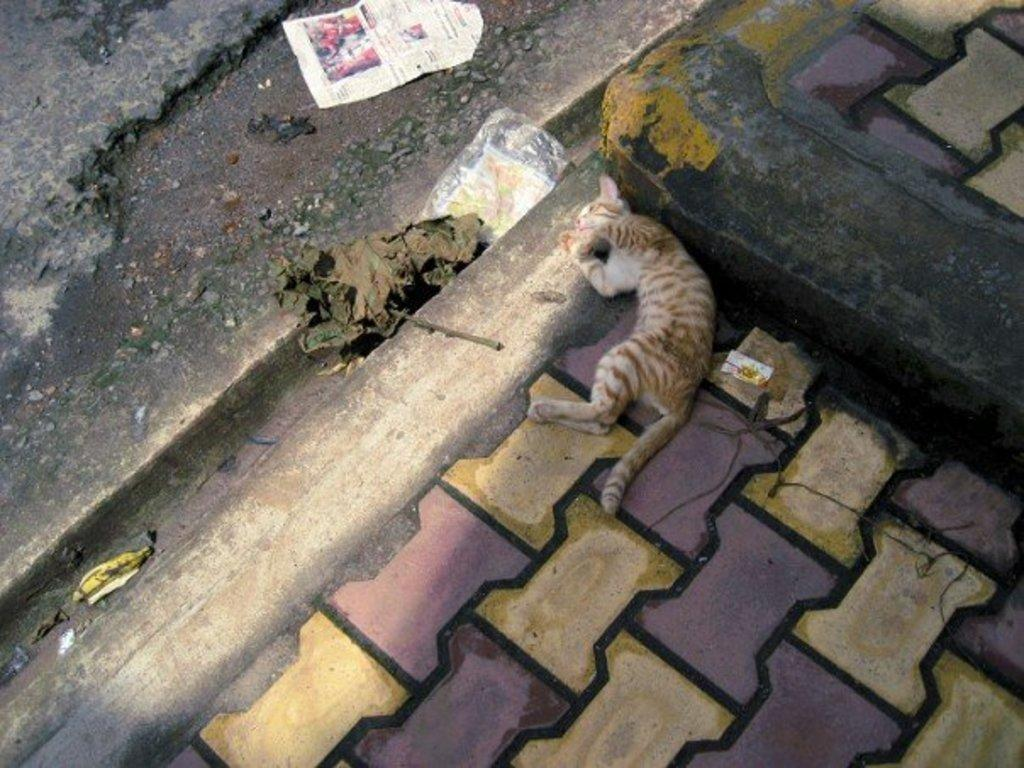What type of animal is on the surface in the image? There is a cat on the surface in the image. What is located on the ground in the image? There is a paper, a cover, a banana peel, and a leaf on the ground in the image. What unit of measurement is used to determine the size of the earth in the image? The image does not depict the earth, nor does it provide any information about units of measurement. 